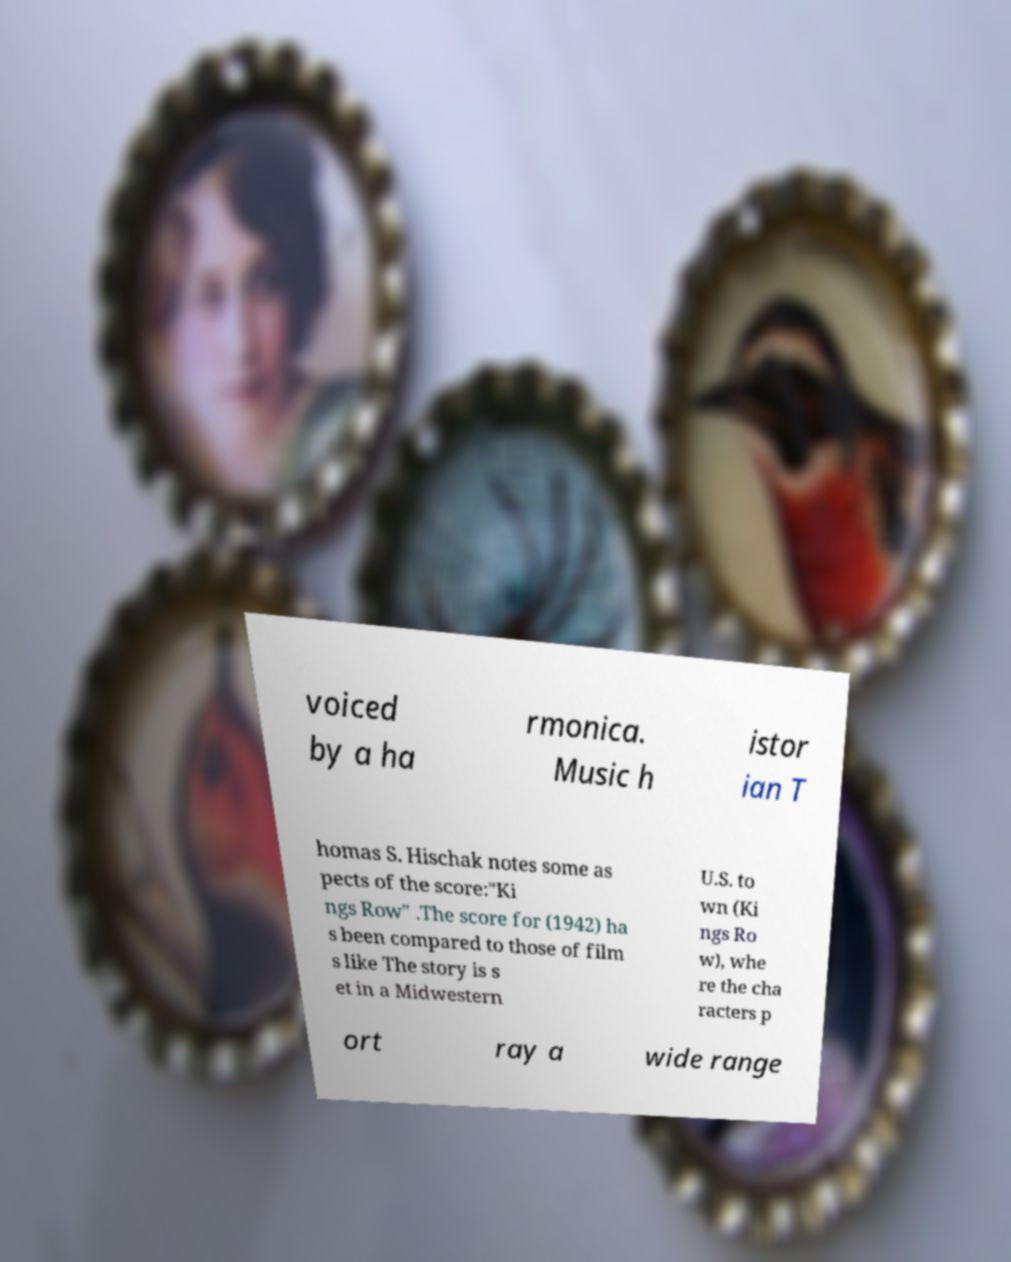There's text embedded in this image that I need extracted. Can you transcribe it verbatim? voiced by a ha rmonica. Music h istor ian T homas S. Hischak notes some as pects of the score:"Ki ngs Row" .The score for (1942) ha s been compared to those of film s like The story is s et in a Midwestern U.S. to wn (Ki ngs Ro w), whe re the cha racters p ort ray a wide range 